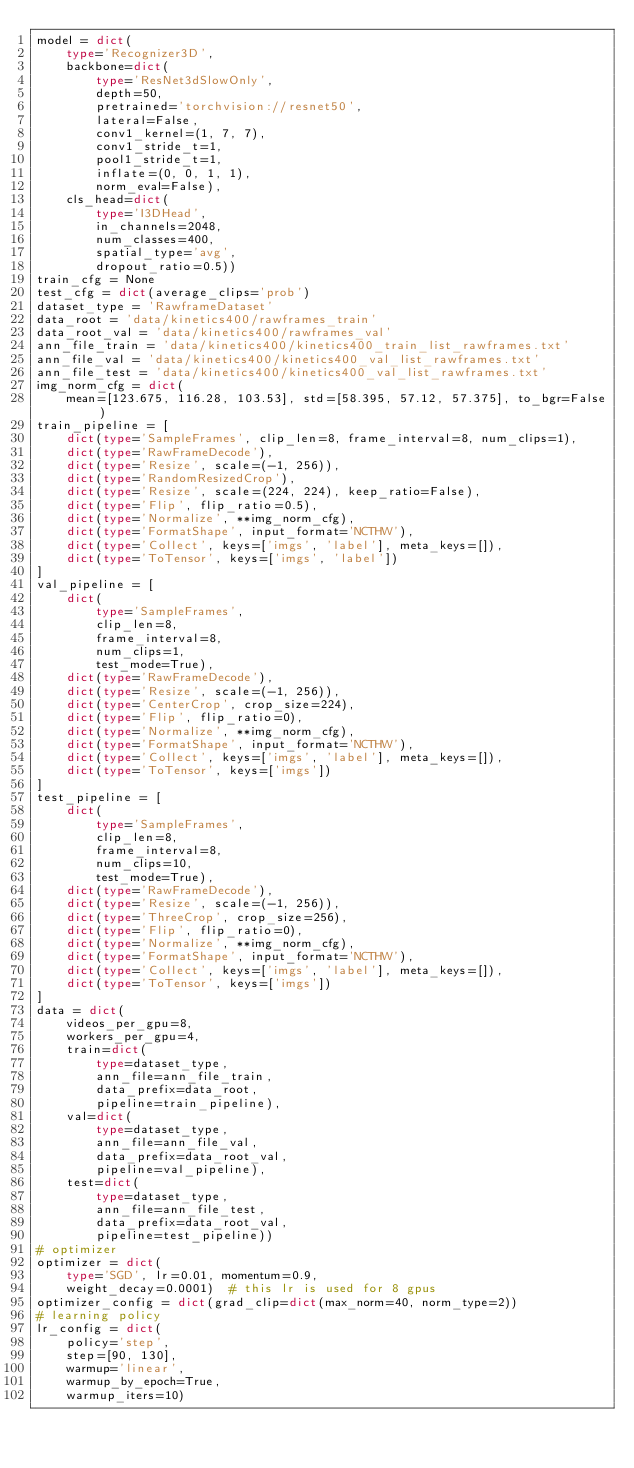<code> <loc_0><loc_0><loc_500><loc_500><_Python_>model = dict(
    type='Recognizer3D',
    backbone=dict(
        type='ResNet3dSlowOnly',
        depth=50,
        pretrained='torchvision://resnet50',
        lateral=False,
        conv1_kernel=(1, 7, 7),
        conv1_stride_t=1,
        pool1_stride_t=1,
        inflate=(0, 0, 1, 1),
        norm_eval=False),
    cls_head=dict(
        type='I3DHead',
        in_channels=2048,
        num_classes=400,
        spatial_type='avg',
        dropout_ratio=0.5))
train_cfg = None
test_cfg = dict(average_clips='prob')
dataset_type = 'RawframeDataset'
data_root = 'data/kinetics400/rawframes_train'
data_root_val = 'data/kinetics400/rawframes_val'
ann_file_train = 'data/kinetics400/kinetics400_train_list_rawframes.txt'
ann_file_val = 'data/kinetics400/kinetics400_val_list_rawframes.txt'
ann_file_test = 'data/kinetics400/kinetics400_val_list_rawframes.txt'
img_norm_cfg = dict(
    mean=[123.675, 116.28, 103.53], std=[58.395, 57.12, 57.375], to_bgr=False)
train_pipeline = [
    dict(type='SampleFrames', clip_len=8, frame_interval=8, num_clips=1),
    dict(type='RawFrameDecode'),
    dict(type='Resize', scale=(-1, 256)),
    dict(type='RandomResizedCrop'),
    dict(type='Resize', scale=(224, 224), keep_ratio=False),
    dict(type='Flip', flip_ratio=0.5),
    dict(type='Normalize', **img_norm_cfg),
    dict(type='FormatShape', input_format='NCTHW'),
    dict(type='Collect', keys=['imgs', 'label'], meta_keys=[]),
    dict(type='ToTensor', keys=['imgs', 'label'])
]
val_pipeline = [
    dict(
        type='SampleFrames',
        clip_len=8,
        frame_interval=8,
        num_clips=1,
        test_mode=True),
    dict(type='RawFrameDecode'),
    dict(type='Resize', scale=(-1, 256)),
    dict(type='CenterCrop', crop_size=224),
    dict(type='Flip', flip_ratio=0),
    dict(type='Normalize', **img_norm_cfg),
    dict(type='FormatShape', input_format='NCTHW'),
    dict(type='Collect', keys=['imgs', 'label'], meta_keys=[]),
    dict(type='ToTensor', keys=['imgs'])
]
test_pipeline = [
    dict(
        type='SampleFrames',
        clip_len=8,
        frame_interval=8,
        num_clips=10,
        test_mode=True),
    dict(type='RawFrameDecode'),
    dict(type='Resize', scale=(-1, 256)),
    dict(type='ThreeCrop', crop_size=256),
    dict(type='Flip', flip_ratio=0),
    dict(type='Normalize', **img_norm_cfg),
    dict(type='FormatShape', input_format='NCTHW'),
    dict(type='Collect', keys=['imgs', 'label'], meta_keys=[]),
    dict(type='ToTensor', keys=['imgs'])
]
data = dict(
    videos_per_gpu=8,
    workers_per_gpu=4,
    train=dict(
        type=dataset_type,
        ann_file=ann_file_train,
        data_prefix=data_root,
        pipeline=train_pipeline),
    val=dict(
        type=dataset_type,
        ann_file=ann_file_val,
        data_prefix=data_root_val,
        pipeline=val_pipeline),
    test=dict(
        type=dataset_type,
        ann_file=ann_file_test,
        data_prefix=data_root_val,
        pipeline=test_pipeline))
# optimizer
optimizer = dict(
    type='SGD', lr=0.01, momentum=0.9,
    weight_decay=0.0001)  # this lr is used for 8 gpus
optimizer_config = dict(grad_clip=dict(max_norm=40, norm_type=2))
# learning policy
lr_config = dict(
    policy='step',
    step=[90, 130],
    warmup='linear',
    warmup_by_epoch=True,
    warmup_iters=10)</code> 